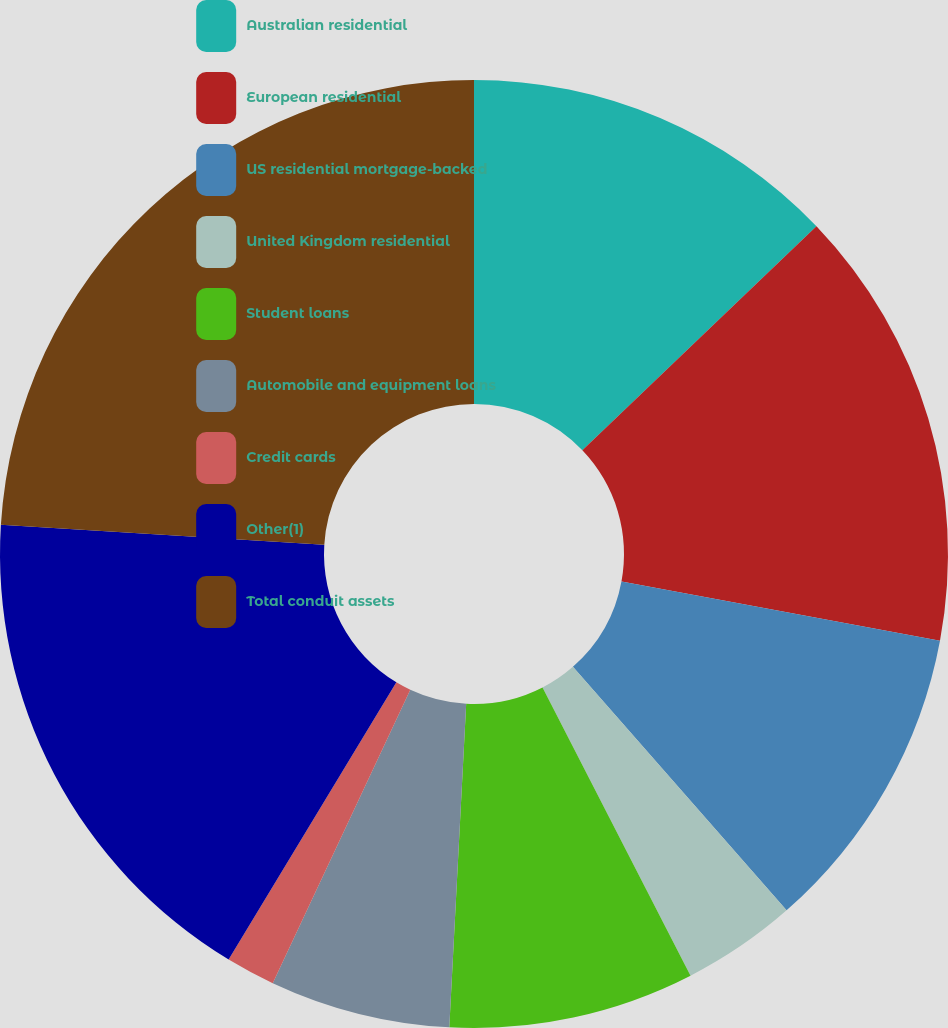Convert chart. <chart><loc_0><loc_0><loc_500><loc_500><pie_chart><fcel>Australian residential<fcel>European residential<fcel>US residential mortgage-backed<fcel>United Kingdom residential<fcel>Student loans<fcel>Automobile and equipment loans<fcel>Credit cards<fcel>Other(1)<fcel>Total conduit assets<nl><fcel>12.85%<fcel>15.08%<fcel>10.61%<fcel>3.91%<fcel>8.38%<fcel>6.15%<fcel>1.68%<fcel>17.32%<fcel>24.02%<nl></chart> 